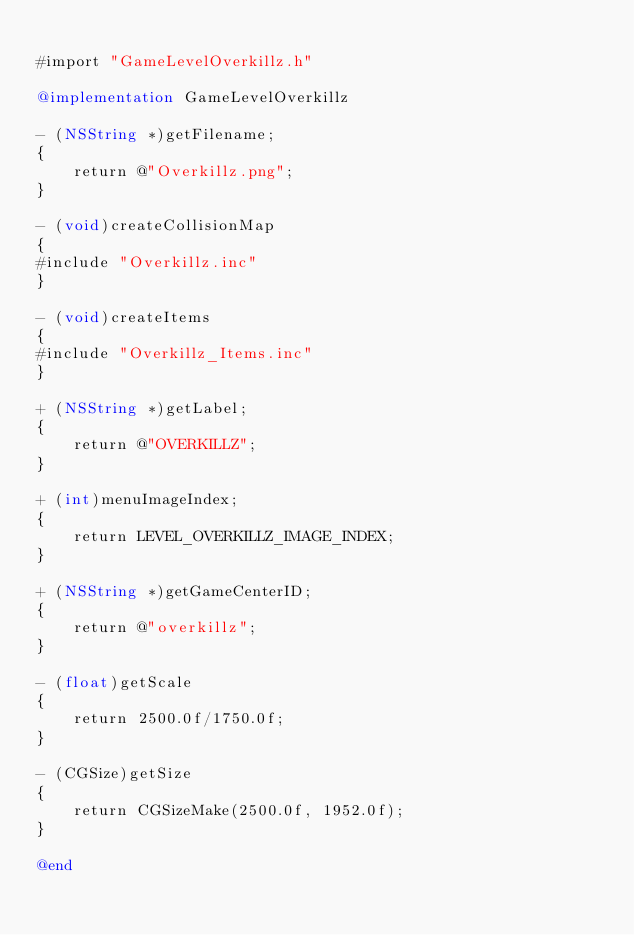<code> <loc_0><loc_0><loc_500><loc_500><_ObjectiveC_>
#import "GameLevelOverkillz.h"

@implementation GameLevelOverkillz

- (NSString *)getFilename;
{
    return @"Overkillz.png";
}

- (void)createCollisionMap
{
#include "Overkillz.inc"
}

- (void)createItems
{
#include "Overkillz_Items.inc"
}

+ (NSString *)getLabel;
{
    return @"OVERKILLZ";
}

+ (int)menuImageIndex;
{
    return LEVEL_OVERKILLZ_IMAGE_INDEX;
}

+ (NSString *)getGameCenterID;
{
    return @"overkillz";
}

- (float)getScale
{
    return 2500.0f/1750.0f;
}

- (CGSize)getSize
{
    return CGSizeMake(2500.0f, 1952.0f);
}

@end
</code> 